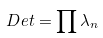<formula> <loc_0><loc_0><loc_500><loc_500>\ D e t = \prod \lambda _ { n }</formula> 